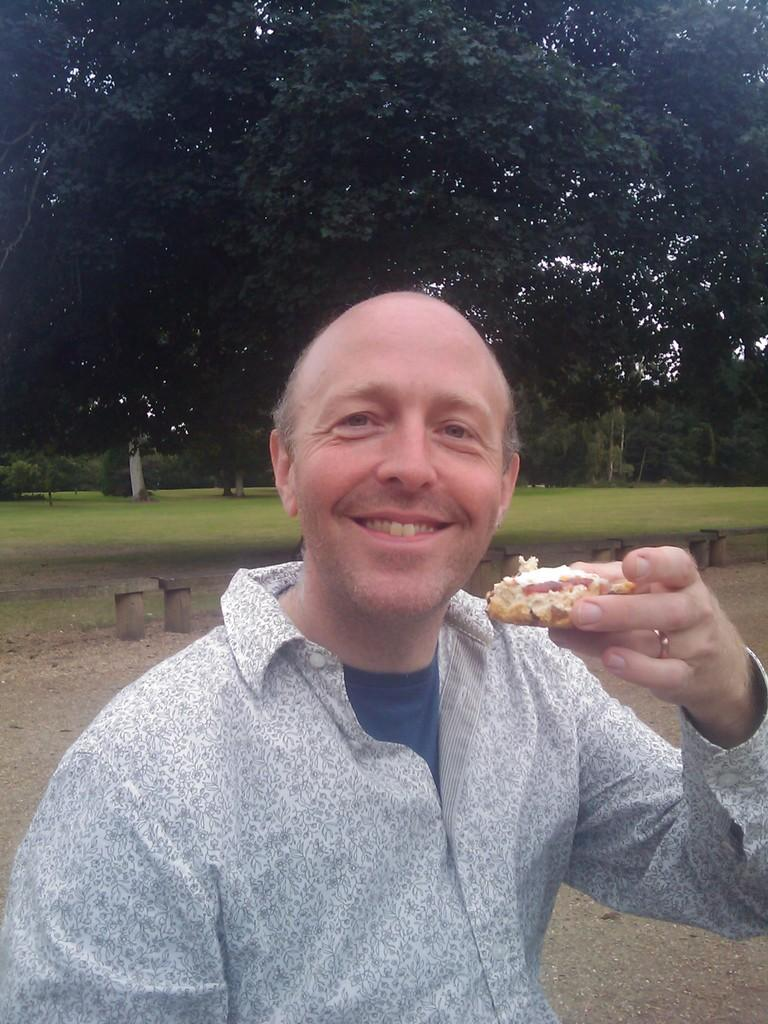What is the main subject of the image? There is a man in the image. What is the man holding in the image? The man is holding a food item. What can be seen behind the man in the image? There are benches behind the man. What type of natural environment is visible in the image? There is grass visible in the image, and trees and the sky are visible in the background. What type of songs can be heard coming from the basket in the image? There is no basket present in the image, and therefore no songs can be heard coming from it. 